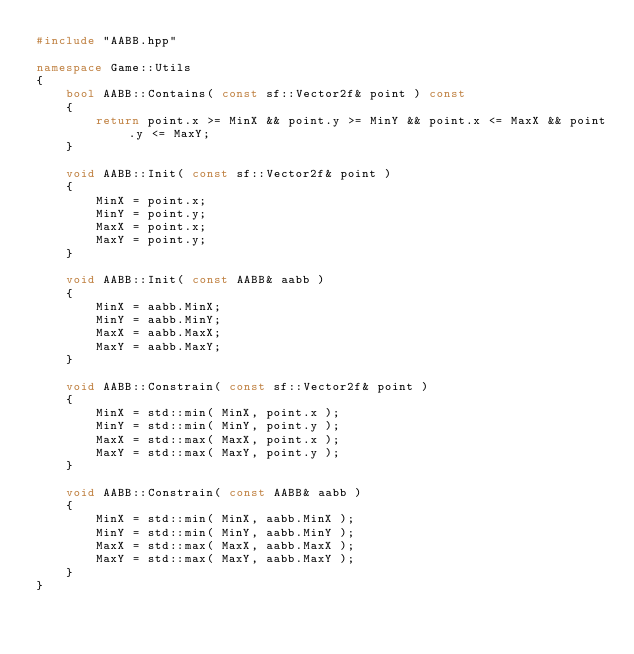<code> <loc_0><loc_0><loc_500><loc_500><_C++_>#include "AABB.hpp"

namespace Game::Utils
{
    bool AABB::Contains( const sf::Vector2f& point ) const
    {
        return point.x >= MinX && point.y >= MinY && point.x <= MaxX && point.y <= MaxY;
    }

    void AABB::Init( const sf::Vector2f& point )
    {
        MinX = point.x;
        MinY = point.y;
        MaxX = point.x;
        MaxY = point.y;
    }

    void AABB::Init( const AABB& aabb )
    {
        MinX = aabb.MinX;
        MinY = aabb.MinY;
        MaxX = aabb.MaxX;
        MaxY = aabb.MaxY;
    }

    void AABB::Constrain( const sf::Vector2f& point )
    {
        MinX = std::min( MinX, point.x );
        MinY = std::min( MinY, point.y );
        MaxX = std::max( MaxX, point.x );
        MaxY = std::max( MaxY, point.y );
    }

    void AABB::Constrain( const AABB& aabb )
    {
        MinX = std::min( MinX, aabb.MinX );
        MinY = std::min( MinY, aabb.MinY );
        MaxX = std::max( MaxX, aabb.MaxX );
        MaxY = std::max( MaxY, aabb.MaxY );
    }
}
</code> 